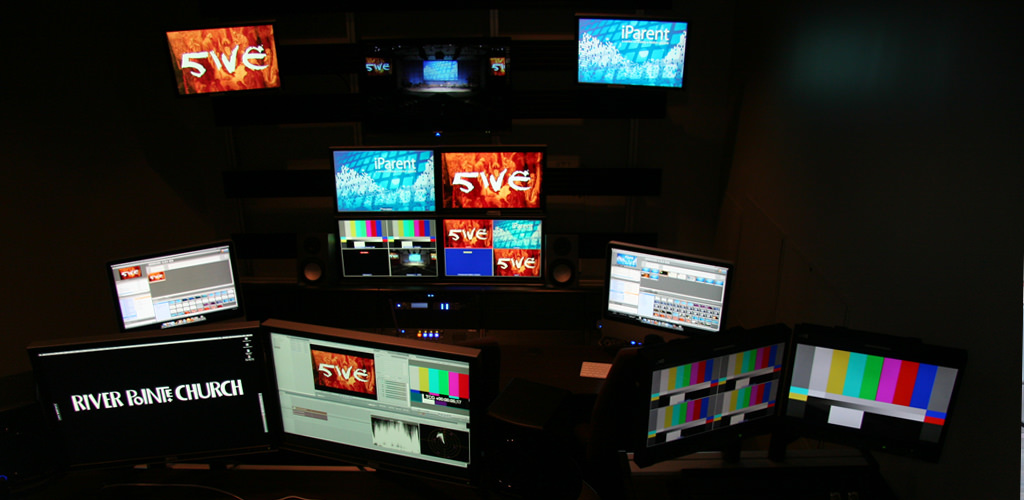What specific activities might be taking place in this room based on the equipment visible? This room is likely used for video production and broadcasting activities. The presence of sophisticated software and multiple screens allows for real-time editing, broadcasting, and perhaps even livestreaming events or services, like those of the River Pointe Church. 